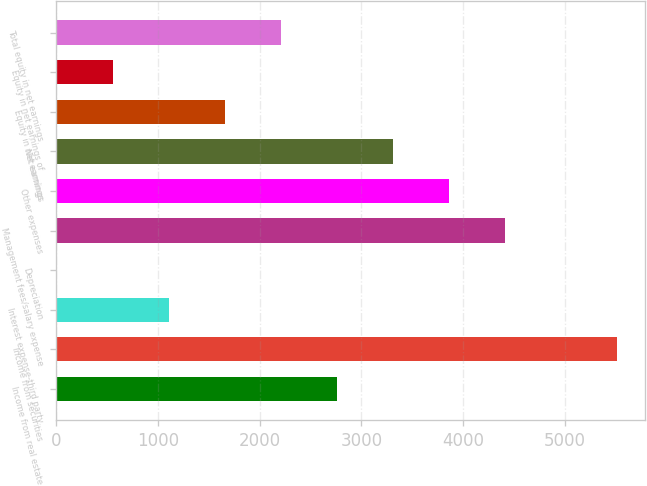<chart> <loc_0><loc_0><loc_500><loc_500><bar_chart><fcel>Income from real estate<fcel>Income from securities<fcel>Interest expense-third party<fcel>Depreciation<fcel>Management fees/salary expense<fcel>Other expenses<fcel>Net earnings<fcel>Equity in net earnings<fcel>Equity in net earnings of<fcel>Total equity in net earnings<nl><fcel>2759.5<fcel>5510<fcel>1109.2<fcel>9<fcel>4409.8<fcel>3859.7<fcel>3309.6<fcel>1659.3<fcel>559.1<fcel>2209.4<nl></chart> 